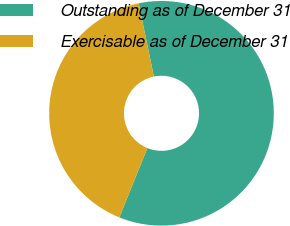Convert chart to OTSL. <chart><loc_0><loc_0><loc_500><loc_500><pie_chart><fcel>Outstanding as of December 31<fcel>Exercisable as of December 31<nl><fcel>59.38%<fcel>40.62%<nl></chart> 